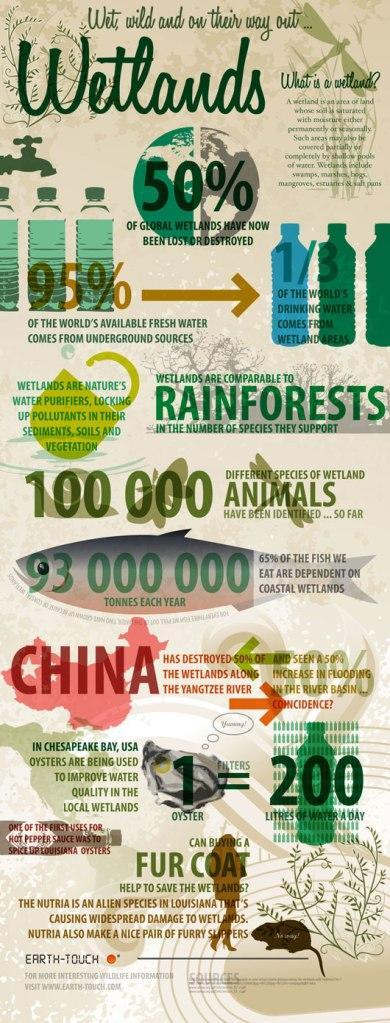How many oysters are required to improve the quality of 200 litres of water?
Answer the question with a short phrase. 1 